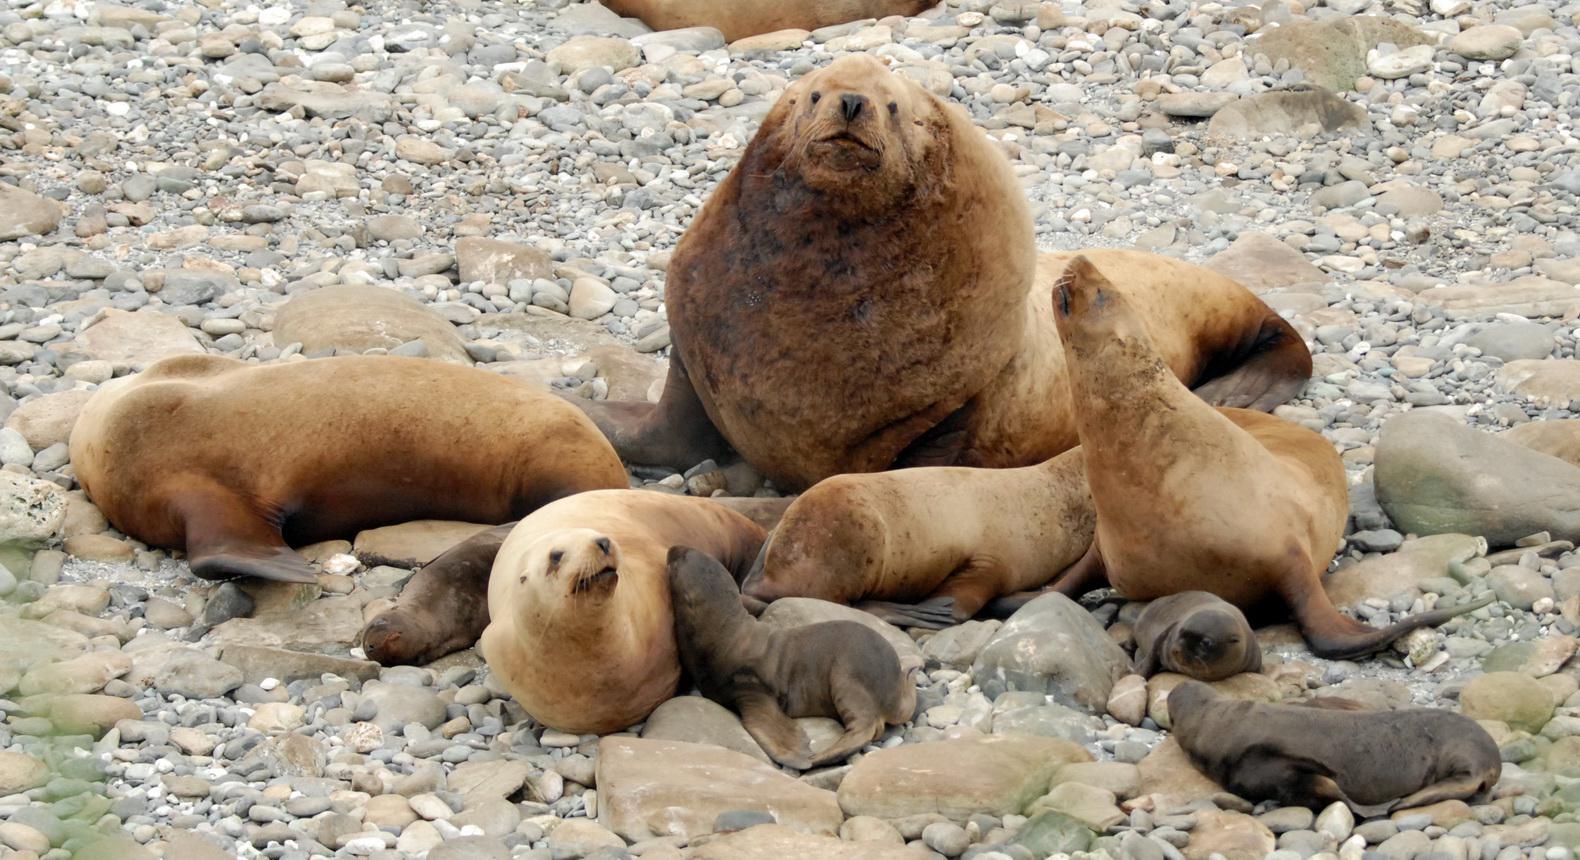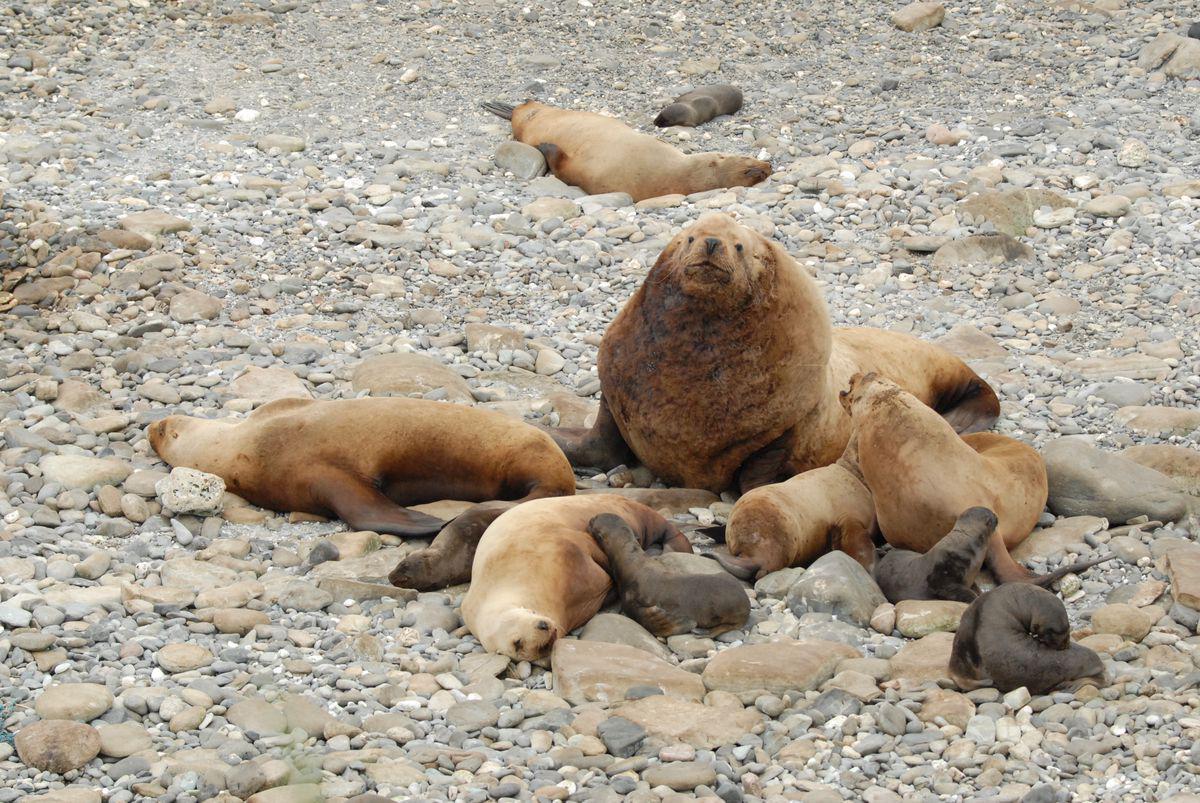The first image is the image on the left, the second image is the image on the right. Considering the images on both sides, is "An image shows exactly one dark baby seal in contact with a larger, paler seal." valid? Answer yes or no. No. The first image is the image on the left, the second image is the image on the right. Given the left and right images, does the statement "Two seals are bonding in one of the images." hold true? Answer yes or no. No. 